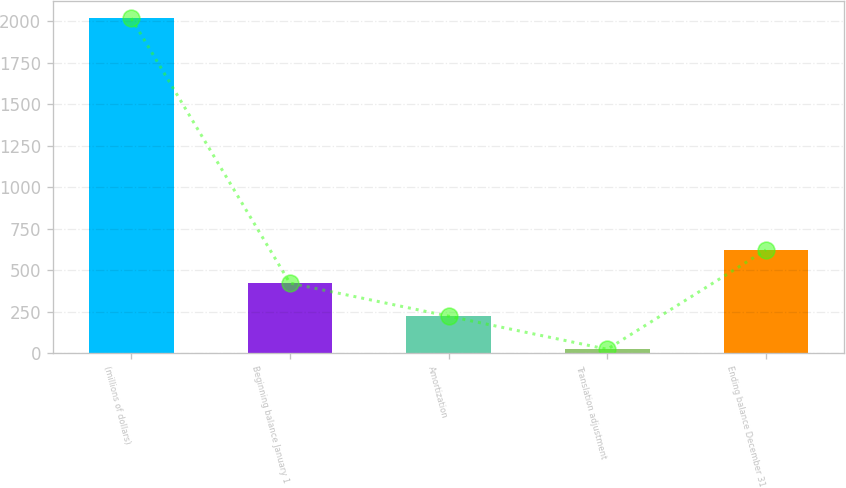<chart> <loc_0><loc_0><loc_500><loc_500><bar_chart><fcel>(millions of dollars)<fcel>Beginning balance January 1<fcel>Amortization<fcel>Translation adjustment<fcel>Ending balance December 31<nl><fcel>2017<fcel>421.48<fcel>222.04<fcel>22.6<fcel>620.92<nl></chart> 